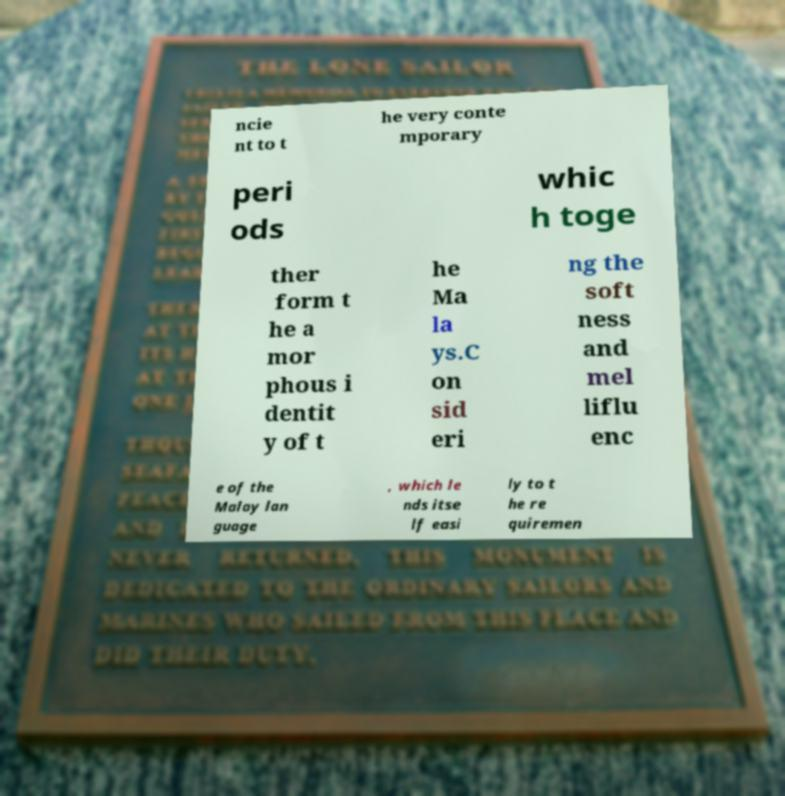Can you read and provide the text displayed in the image?This photo seems to have some interesting text. Can you extract and type it out for me? ncie nt to t he very conte mporary peri ods whic h toge ther form t he a mor phous i dentit y of t he Ma la ys.C on sid eri ng the soft ness and mel liflu enc e of the Malay lan guage , which le nds itse lf easi ly to t he re quiremen 